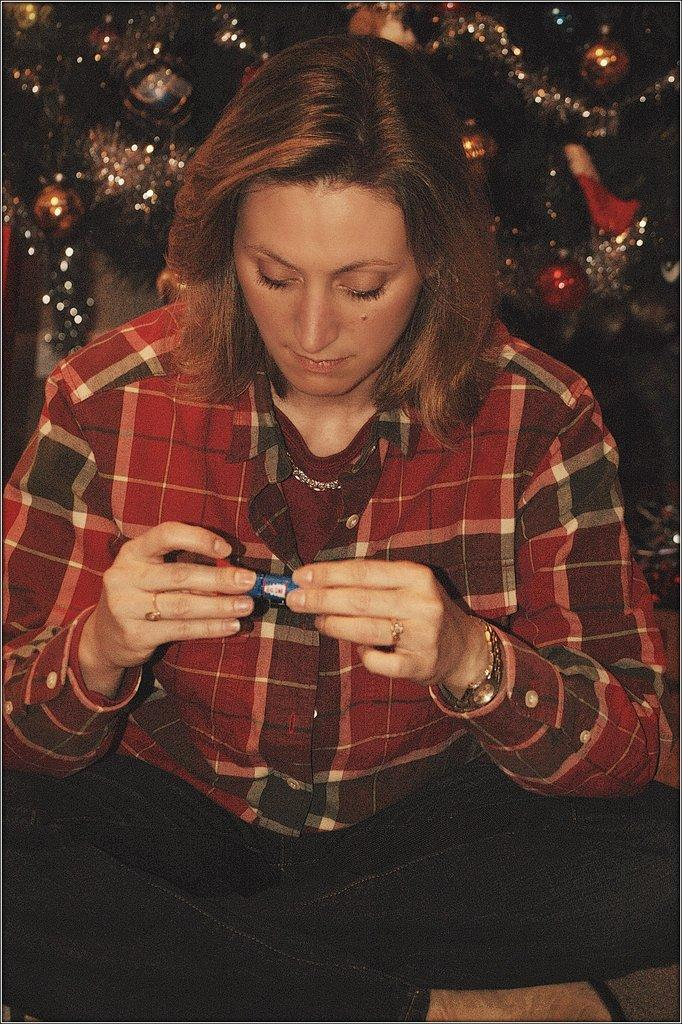Who is present in the image? There is a woman in the image. What is the woman holding in the image? The woman is holding an object. What can be seen in the background of the image? There are decorative items visible behind the woman. What type of tax is being discussed by the woman in the image? There is no indication in the image that the woman is discussing any type of tax. 